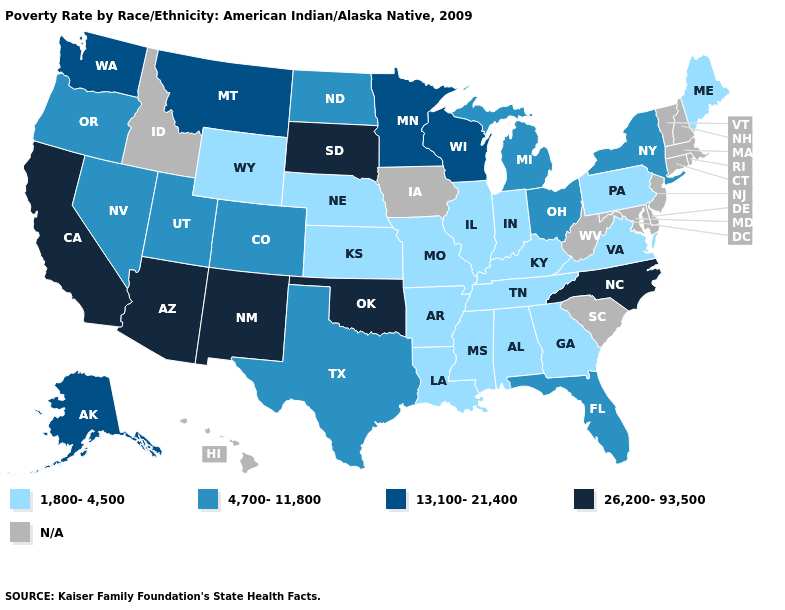Name the states that have a value in the range 26,200-93,500?
Answer briefly. Arizona, California, New Mexico, North Carolina, Oklahoma, South Dakota. Name the states that have a value in the range 1,800-4,500?
Keep it brief. Alabama, Arkansas, Georgia, Illinois, Indiana, Kansas, Kentucky, Louisiana, Maine, Mississippi, Missouri, Nebraska, Pennsylvania, Tennessee, Virginia, Wyoming. What is the value of Michigan?
Give a very brief answer. 4,700-11,800. Among the states that border Illinois , does Wisconsin have the highest value?
Write a very short answer. Yes. What is the value of Vermont?
Give a very brief answer. N/A. Name the states that have a value in the range 26,200-93,500?
Concise answer only. Arizona, California, New Mexico, North Carolina, Oklahoma, South Dakota. What is the lowest value in the South?
Give a very brief answer. 1,800-4,500. What is the highest value in states that border Tennessee?
Answer briefly. 26,200-93,500. Name the states that have a value in the range 13,100-21,400?
Keep it brief. Alaska, Minnesota, Montana, Washington, Wisconsin. Which states have the lowest value in the USA?
Quick response, please. Alabama, Arkansas, Georgia, Illinois, Indiana, Kansas, Kentucky, Louisiana, Maine, Mississippi, Missouri, Nebraska, Pennsylvania, Tennessee, Virginia, Wyoming. What is the lowest value in states that border Montana?
Keep it brief. 1,800-4,500. Does the map have missing data?
Short answer required. Yes. What is the value of West Virginia?
Answer briefly. N/A. Does Utah have the highest value in the West?
Keep it brief. No. Name the states that have a value in the range 4,700-11,800?
Keep it brief. Colorado, Florida, Michigan, Nevada, New York, North Dakota, Ohio, Oregon, Texas, Utah. 